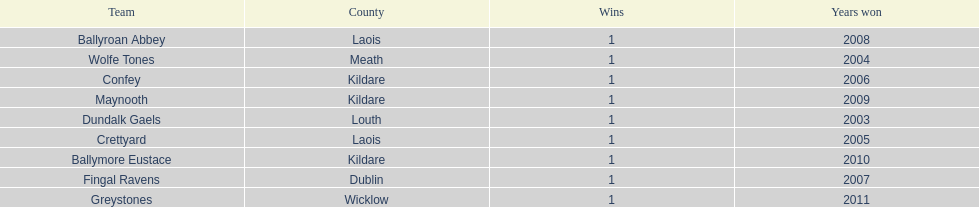Which team was the previous winner before ballyroan abbey in 2008? Fingal Ravens. 